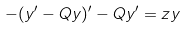<formula> <loc_0><loc_0><loc_500><loc_500>- ( y ^ { \prime } - Q y ) ^ { \prime } - Q y ^ { \prime } = z y</formula> 